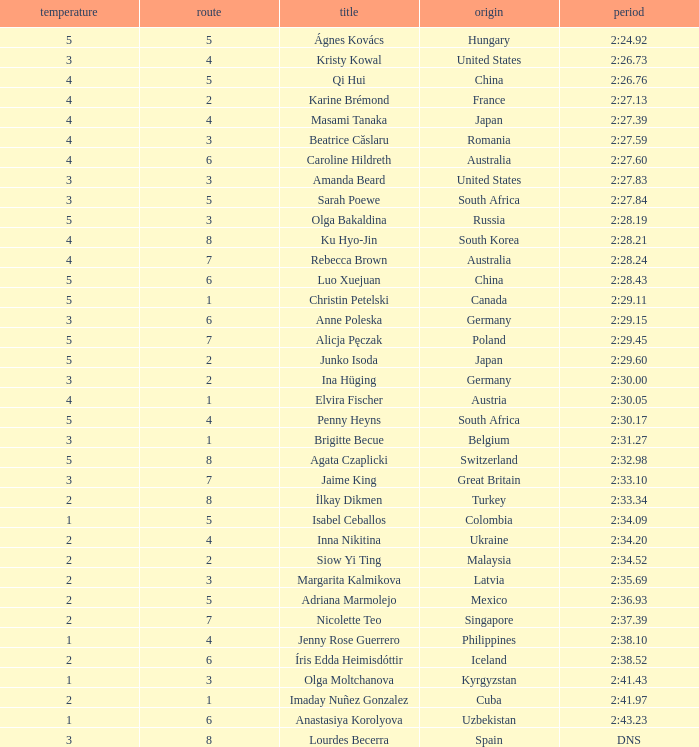What lane did inna nikitina have? 4.0. 